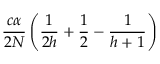<formula> <loc_0><loc_0><loc_500><loc_500>\frac { c \alpha } { 2 N } \left ( \frac { 1 } { 2 h } + \frac { 1 } { 2 } - \frac { 1 } { h + 1 } \right )</formula> 